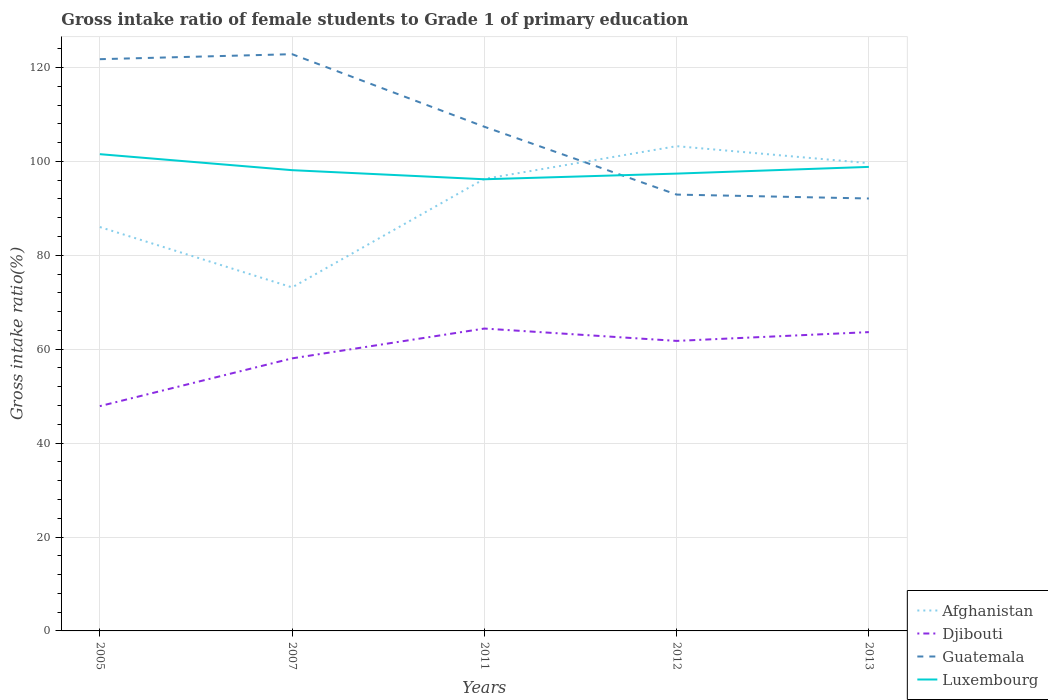Is the number of lines equal to the number of legend labels?
Keep it short and to the point. Yes. Across all years, what is the maximum gross intake ratio in Afghanistan?
Give a very brief answer. 73.16. In which year was the gross intake ratio in Luxembourg maximum?
Your answer should be compact. 2011. What is the total gross intake ratio in Guatemala in the graph?
Your response must be concise. 14.45. What is the difference between the highest and the second highest gross intake ratio in Djibouti?
Offer a very short reply. 16.52. What is the difference between the highest and the lowest gross intake ratio in Luxembourg?
Give a very brief answer. 2. How many lines are there?
Your answer should be compact. 4. What is the difference between two consecutive major ticks on the Y-axis?
Offer a very short reply. 20. Are the values on the major ticks of Y-axis written in scientific E-notation?
Keep it short and to the point. No. Does the graph contain any zero values?
Provide a short and direct response. No. Where does the legend appear in the graph?
Keep it short and to the point. Bottom right. How many legend labels are there?
Your answer should be compact. 4. How are the legend labels stacked?
Provide a short and direct response. Vertical. What is the title of the graph?
Keep it short and to the point. Gross intake ratio of female students to Grade 1 of primary education. Does "Sudan" appear as one of the legend labels in the graph?
Give a very brief answer. No. What is the label or title of the Y-axis?
Your answer should be compact. Gross intake ratio(%). What is the Gross intake ratio(%) of Afghanistan in 2005?
Provide a short and direct response. 86.01. What is the Gross intake ratio(%) in Djibouti in 2005?
Ensure brevity in your answer.  47.87. What is the Gross intake ratio(%) of Guatemala in 2005?
Keep it short and to the point. 121.76. What is the Gross intake ratio(%) in Luxembourg in 2005?
Your answer should be very brief. 101.53. What is the Gross intake ratio(%) of Afghanistan in 2007?
Provide a short and direct response. 73.16. What is the Gross intake ratio(%) of Djibouti in 2007?
Make the answer very short. 58.04. What is the Gross intake ratio(%) of Guatemala in 2007?
Ensure brevity in your answer.  122.83. What is the Gross intake ratio(%) of Luxembourg in 2007?
Offer a terse response. 98.12. What is the Gross intake ratio(%) of Afghanistan in 2011?
Provide a short and direct response. 96.27. What is the Gross intake ratio(%) of Djibouti in 2011?
Ensure brevity in your answer.  64.39. What is the Gross intake ratio(%) in Guatemala in 2011?
Ensure brevity in your answer.  107.37. What is the Gross intake ratio(%) in Luxembourg in 2011?
Give a very brief answer. 96.19. What is the Gross intake ratio(%) of Afghanistan in 2012?
Offer a terse response. 103.24. What is the Gross intake ratio(%) of Djibouti in 2012?
Keep it short and to the point. 61.76. What is the Gross intake ratio(%) in Guatemala in 2012?
Provide a short and direct response. 92.92. What is the Gross intake ratio(%) of Luxembourg in 2012?
Make the answer very short. 97.39. What is the Gross intake ratio(%) in Afghanistan in 2013?
Provide a succinct answer. 99.62. What is the Gross intake ratio(%) of Djibouti in 2013?
Offer a very short reply. 63.64. What is the Gross intake ratio(%) in Guatemala in 2013?
Your answer should be very brief. 92.09. What is the Gross intake ratio(%) of Luxembourg in 2013?
Keep it short and to the point. 98.82. Across all years, what is the maximum Gross intake ratio(%) in Afghanistan?
Provide a succinct answer. 103.24. Across all years, what is the maximum Gross intake ratio(%) in Djibouti?
Offer a terse response. 64.39. Across all years, what is the maximum Gross intake ratio(%) in Guatemala?
Keep it short and to the point. 122.83. Across all years, what is the maximum Gross intake ratio(%) in Luxembourg?
Keep it short and to the point. 101.53. Across all years, what is the minimum Gross intake ratio(%) of Afghanistan?
Keep it short and to the point. 73.16. Across all years, what is the minimum Gross intake ratio(%) of Djibouti?
Your response must be concise. 47.87. Across all years, what is the minimum Gross intake ratio(%) of Guatemala?
Provide a short and direct response. 92.09. Across all years, what is the minimum Gross intake ratio(%) in Luxembourg?
Your answer should be very brief. 96.19. What is the total Gross intake ratio(%) in Afghanistan in the graph?
Ensure brevity in your answer.  458.29. What is the total Gross intake ratio(%) in Djibouti in the graph?
Your answer should be very brief. 295.71. What is the total Gross intake ratio(%) of Guatemala in the graph?
Ensure brevity in your answer.  536.97. What is the total Gross intake ratio(%) in Luxembourg in the graph?
Make the answer very short. 492.05. What is the difference between the Gross intake ratio(%) of Afghanistan in 2005 and that in 2007?
Your response must be concise. 12.85. What is the difference between the Gross intake ratio(%) of Djibouti in 2005 and that in 2007?
Your answer should be very brief. -10.17. What is the difference between the Gross intake ratio(%) of Guatemala in 2005 and that in 2007?
Offer a very short reply. -1.07. What is the difference between the Gross intake ratio(%) of Luxembourg in 2005 and that in 2007?
Keep it short and to the point. 3.41. What is the difference between the Gross intake ratio(%) of Afghanistan in 2005 and that in 2011?
Your answer should be compact. -10.25. What is the difference between the Gross intake ratio(%) of Djibouti in 2005 and that in 2011?
Your answer should be compact. -16.52. What is the difference between the Gross intake ratio(%) of Guatemala in 2005 and that in 2011?
Provide a short and direct response. 14.39. What is the difference between the Gross intake ratio(%) of Luxembourg in 2005 and that in 2011?
Your response must be concise. 5.34. What is the difference between the Gross intake ratio(%) in Afghanistan in 2005 and that in 2012?
Offer a very short reply. -17.22. What is the difference between the Gross intake ratio(%) in Djibouti in 2005 and that in 2012?
Ensure brevity in your answer.  -13.89. What is the difference between the Gross intake ratio(%) of Guatemala in 2005 and that in 2012?
Provide a succinct answer. 28.83. What is the difference between the Gross intake ratio(%) of Luxembourg in 2005 and that in 2012?
Your answer should be compact. 4.14. What is the difference between the Gross intake ratio(%) in Afghanistan in 2005 and that in 2013?
Provide a short and direct response. -13.61. What is the difference between the Gross intake ratio(%) in Djibouti in 2005 and that in 2013?
Your response must be concise. -15.76. What is the difference between the Gross intake ratio(%) of Guatemala in 2005 and that in 2013?
Offer a terse response. 29.67. What is the difference between the Gross intake ratio(%) in Luxembourg in 2005 and that in 2013?
Make the answer very short. 2.71. What is the difference between the Gross intake ratio(%) in Afghanistan in 2007 and that in 2011?
Your answer should be very brief. -23.1. What is the difference between the Gross intake ratio(%) in Djibouti in 2007 and that in 2011?
Keep it short and to the point. -6.35. What is the difference between the Gross intake ratio(%) of Guatemala in 2007 and that in 2011?
Your answer should be very brief. 15.46. What is the difference between the Gross intake ratio(%) in Luxembourg in 2007 and that in 2011?
Keep it short and to the point. 1.94. What is the difference between the Gross intake ratio(%) in Afghanistan in 2007 and that in 2012?
Give a very brief answer. -30.07. What is the difference between the Gross intake ratio(%) in Djibouti in 2007 and that in 2012?
Your answer should be very brief. -3.72. What is the difference between the Gross intake ratio(%) of Guatemala in 2007 and that in 2012?
Provide a succinct answer. 29.9. What is the difference between the Gross intake ratio(%) of Luxembourg in 2007 and that in 2012?
Provide a succinct answer. 0.73. What is the difference between the Gross intake ratio(%) in Afghanistan in 2007 and that in 2013?
Your response must be concise. -26.46. What is the difference between the Gross intake ratio(%) in Djibouti in 2007 and that in 2013?
Your answer should be very brief. -5.59. What is the difference between the Gross intake ratio(%) of Guatemala in 2007 and that in 2013?
Provide a short and direct response. 30.73. What is the difference between the Gross intake ratio(%) of Luxembourg in 2007 and that in 2013?
Offer a terse response. -0.7. What is the difference between the Gross intake ratio(%) in Afghanistan in 2011 and that in 2012?
Keep it short and to the point. -6.97. What is the difference between the Gross intake ratio(%) in Djibouti in 2011 and that in 2012?
Offer a very short reply. 2.63. What is the difference between the Gross intake ratio(%) of Guatemala in 2011 and that in 2012?
Provide a succinct answer. 14.45. What is the difference between the Gross intake ratio(%) in Luxembourg in 2011 and that in 2012?
Your answer should be compact. -1.21. What is the difference between the Gross intake ratio(%) of Afghanistan in 2011 and that in 2013?
Your answer should be very brief. -3.35. What is the difference between the Gross intake ratio(%) of Djibouti in 2011 and that in 2013?
Offer a terse response. 0.76. What is the difference between the Gross intake ratio(%) of Guatemala in 2011 and that in 2013?
Ensure brevity in your answer.  15.28. What is the difference between the Gross intake ratio(%) of Luxembourg in 2011 and that in 2013?
Keep it short and to the point. -2.64. What is the difference between the Gross intake ratio(%) in Afghanistan in 2012 and that in 2013?
Keep it short and to the point. 3.62. What is the difference between the Gross intake ratio(%) of Djibouti in 2012 and that in 2013?
Your answer should be compact. -1.87. What is the difference between the Gross intake ratio(%) in Guatemala in 2012 and that in 2013?
Give a very brief answer. 0.83. What is the difference between the Gross intake ratio(%) in Luxembourg in 2012 and that in 2013?
Your answer should be compact. -1.43. What is the difference between the Gross intake ratio(%) of Afghanistan in 2005 and the Gross intake ratio(%) of Djibouti in 2007?
Your answer should be very brief. 27.97. What is the difference between the Gross intake ratio(%) of Afghanistan in 2005 and the Gross intake ratio(%) of Guatemala in 2007?
Your answer should be very brief. -36.81. What is the difference between the Gross intake ratio(%) of Afghanistan in 2005 and the Gross intake ratio(%) of Luxembourg in 2007?
Provide a succinct answer. -12.11. What is the difference between the Gross intake ratio(%) of Djibouti in 2005 and the Gross intake ratio(%) of Guatemala in 2007?
Your answer should be very brief. -74.95. What is the difference between the Gross intake ratio(%) in Djibouti in 2005 and the Gross intake ratio(%) in Luxembourg in 2007?
Your answer should be compact. -50.25. What is the difference between the Gross intake ratio(%) in Guatemala in 2005 and the Gross intake ratio(%) in Luxembourg in 2007?
Offer a very short reply. 23.64. What is the difference between the Gross intake ratio(%) in Afghanistan in 2005 and the Gross intake ratio(%) in Djibouti in 2011?
Offer a terse response. 21.62. What is the difference between the Gross intake ratio(%) of Afghanistan in 2005 and the Gross intake ratio(%) of Guatemala in 2011?
Ensure brevity in your answer.  -21.36. What is the difference between the Gross intake ratio(%) of Afghanistan in 2005 and the Gross intake ratio(%) of Luxembourg in 2011?
Ensure brevity in your answer.  -10.17. What is the difference between the Gross intake ratio(%) in Djibouti in 2005 and the Gross intake ratio(%) in Guatemala in 2011?
Offer a terse response. -59.5. What is the difference between the Gross intake ratio(%) of Djibouti in 2005 and the Gross intake ratio(%) of Luxembourg in 2011?
Give a very brief answer. -48.31. What is the difference between the Gross intake ratio(%) of Guatemala in 2005 and the Gross intake ratio(%) of Luxembourg in 2011?
Offer a terse response. 25.57. What is the difference between the Gross intake ratio(%) of Afghanistan in 2005 and the Gross intake ratio(%) of Djibouti in 2012?
Provide a succinct answer. 24.25. What is the difference between the Gross intake ratio(%) of Afghanistan in 2005 and the Gross intake ratio(%) of Guatemala in 2012?
Offer a very short reply. -6.91. What is the difference between the Gross intake ratio(%) of Afghanistan in 2005 and the Gross intake ratio(%) of Luxembourg in 2012?
Offer a terse response. -11.38. What is the difference between the Gross intake ratio(%) in Djibouti in 2005 and the Gross intake ratio(%) in Guatemala in 2012?
Your answer should be very brief. -45.05. What is the difference between the Gross intake ratio(%) in Djibouti in 2005 and the Gross intake ratio(%) in Luxembourg in 2012?
Provide a short and direct response. -49.52. What is the difference between the Gross intake ratio(%) of Guatemala in 2005 and the Gross intake ratio(%) of Luxembourg in 2012?
Ensure brevity in your answer.  24.37. What is the difference between the Gross intake ratio(%) of Afghanistan in 2005 and the Gross intake ratio(%) of Djibouti in 2013?
Offer a terse response. 22.38. What is the difference between the Gross intake ratio(%) of Afghanistan in 2005 and the Gross intake ratio(%) of Guatemala in 2013?
Offer a terse response. -6.08. What is the difference between the Gross intake ratio(%) of Afghanistan in 2005 and the Gross intake ratio(%) of Luxembourg in 2013?
Make the answer very short. -12.81. What is the difference between the Gross intake ratio(%) in Djibouti in 2005 and the Gross intake ratio(%) in Guatemala in 2013?
Provide a short and direct response. -44.22. What is the difference between the Gross intake ratio(%) in Djibouti in 2005 and the Gross intake ratio(%) in Luxembourg in 2013?
Your response must be concise. -50.95. What is the difference between the Gross intake ratio(%) in Guatemala in 2005 and the Gross intake ratio(%) in Luxembourg in 2013?
Make the answer very short. 22.93. What is the difference between the Gross intake ratio(%) in Afghanistan in 2007 and the Gross intake ratio(%) in Djibouti in 2011?
Keep it short and to the point. 8.77. What is the difference between the Gross intake ratio(%) of Afghanistan in 2007 and the Gross intake ratio(%) of Guatemala in 2011?
Your answer should be very brief. -34.21. What is the difference between the Gross intake ratio(%) of Afghanistan in 2007 and the Gross intake ratio(%) of Luxembourg in 2011?
Your answer should be compact. -23.02. What is the difference between the Gross intake ratio(%) of Djibouti in 2007 and the Gross intake ratio(%) of Guatemala in 2011?
Keep it short and to the point. -49.33. What is the difference between the Gross intake ratio(%) in Djibouti in 2007 and the Gross intake ratio(%) in Luxembourg in 2011?
Your answer should be very brief. -38.14. What is the difference between the Gross intake ratio(%) in Guatemala in 2007 and the Gross intake ratio(%) in Luxembourg in 2011?
Ensure brevity in your answer.  26.64. What is the difference between the Gross intake ratio(%) in Afghanistan in 2007 and the Gross intake ratio(%) in Djibouti in 2012?
Your response must be concise. 11.4. What is the difference between the Gross intake ratio(%) of Afghanistan in 2007 and the Gross intake ratio(%) of Guatemala in 2012?
Offer a terse response. -19.76. What is the difference between the Gross intake ratio(%) of Afghanistan in 2007 and the Gross intake ratio(%) of Luxembourg in 2012?
Provide a short and direct response. -24.23. What is the difference between the Gross intake ratio(%) in Djibouti in 2007 and the Gross intake ratio(%) in Guatemala in 2012?
Give a very brief answer. -34.88. What is the difference between the Gross intake ratio(%) in Djibouti in 2007 and the Gross intake ratio(%) in Luxembourg in 2012?
Provide a succinct answer. -39.35. What is the difference between the Gross intake ratio(%) in Guatemala in 2007 and the Gross intake ratio(%) in Luxembourg in 2012?
Your answer should be very brief. 25.43. What is the difference between the Gross intake ratio(%) in Afghanistan in 2007 and the Gross intake ratio(%) in Djibouti in 2013?
Keep it short and to the point. 9.53. What is the difference between the Gross intake ratio(%) of Afghanistan in 2007 and the Gross intake ratio(%) of Guatemala in 2013?
Make the answer very short. -18.93. What is the difference between the Gross intake ratio(%) in Afghanistan in 2007 and the Gross intake ratio(%) in Luxembourg in 2013?
Keep it short and to the point. -25.66. What is the difference between the Gross intake ratio(%) of Djibouti in 2007 and the Gross intake ratio(%) of Guatemala in 2013?
Make the answer very short. -34.05. What is the difference between the Gross intake ratio(%) of Djibouti in 2007 and the Gross intake ratio(%) of Luxembourg in 2013?
Your answer should be very brief. -40.78. What is the difference between the Gross intake ratio(%) of Guatemala in 2007 and the Gross intake ratio(%) of Luxembourg in 2013?
Ensure brevity in your answer.  24. What is the difference between the Gross intake ratio(%) in Afghanistan in 2011 and the Gross intake ratio(%) in Djibouti in 2012?
Ensure brevity in your answer.  34.5. What is the difference between the Gross intake ratio(%) in Afghanistan in 2011 and the Gross intake ratio(%) in Guatemala in 2012?
Provide a succinct answer. 3.34. What is the difference between the Gross intake ratio(%) in Afghanistan in 2011 and the Gross intake ratio(%) in Luxembourg in 2012?
Ensure brevity in your answer.  -1.13. What is the difference between the Gross intake ratio(%) in Djibouti in 2011 and the Gross intake ratio(%) in Guatemala in 2012?
Ensure brevity in your answer.  -28.53. What is the difference between the Gross intake ratio(%) in Djibouti in 2011 and the Gross intake ratio(%) in Luxembourg in 2012?
Make the answer very short. -33. What is the difference between the Gross intake ratio(%) in Guatemala in 2011 and the Gross intake ratio(%) in Luxembourg in 2012?
Ensure brevity in your answer.  9.98. What is the difference between the Gross intake ratio(%) of Afghanistan in 2011 and the Gross intake ratio(%) of Djibouti in 2013?
Keep it short and to the point. 32.63. What is the difference between the Gross intake ratio(%) in Afghanistan in 2011 and the Gross intake ratio(%) in Guatemala in 2013?
Your response must be concise. 4.17. What is the difference between the Gross intake ratio(%) in Afghanistan in 2011 and the Gross intake ratio(%) in Luxembourg in 2013?
Keep it short and to the point. -2.56. What is the difference between the Gross intake ratio(%) of Djibouti in 2011 and the Gross intake ratio(%) of Guatemala in 2013?
Offer a very short reply. -27.7. What is the difference between the Gross intake ratio(%) of Djibouti in 2011 and the Gross intake ratio(%) of Luxembourg in 2013?
Give a very brief answer. -34.43. What is the difference between the Gross intake ratio(%) of Guatemala in 2011 and the Gross intake ratio(%) of Luxembourg in 2013?
Your answer should be compact. 8.55. What is the difference between the Gross intake ratio(%) of Afghanistan in 2012 and the Gross intake ratio(%) of Djibouti in 2013?
Your answer should be very brief. 39.6. What is the difference between the Gross intake ratio(%) of Afghanistan in 2012 and the Gross intake ratio(%) of Guatemala in 2013?
Ensure brevity in your answer.  11.14. What is the difference between the Gross intake ratio(%) of Afghanistan in 2012 and the Gross intake ratio(%) of Luxembourg in 2013?
Make the answer very short. 4.41. What is the difference between the Gross intake ratio(%) of Djibouti in 2012 and the Gross intake ratio(%) of Guatemala in 2013?
Ensure brevity in your answer.  -30.33. What is the difference between the Gross intake ratio(%) in Djibouti in 2012 and the Gross intake ratio(%) in Luxembourg in 2013?
Provide a short and direct response. -37.06. What is the difference between the Gross intake ratio(%) in Guatemala in 2012 and the Gross intake ratio(%) in Luxembourg in 2013?
Your answer should be very brief. -5.9. What is the average Gross intake ratio(%) of Afghanistan per year?
Your answer should be very brief. 91.66. What is the average Gross intake ratio(%) in Djibouti per year?
Offer a terse response. 59.14. What is the average Gross intake ratio(%) in Guatemala per year?
Give a very brief answer. 107.39. What is the average Gross intake ratio(%) of Luxembourg per year?
Give a very brief answer. 98.41. In the year 2005, what is the difference between the Gross intake ratio(%) of Afghanistan and Gross intake ratio(%) of Djibouti?
Make the answer very short. 38.14. In the year 2005, what is the difference between the Gross intake ratio(%) in Afghanistan and Gross intake ratio(%) in Guatemala?
Your answer should be compact. -35.74. In the year 2005, what is the difference between the Gross intake ratio(%) of Afghanistan and Gross intake ratio(%) of Luxembourg?
Offer a terse response. -15.52. In the year 2005, what is the difference between the Gross intake ratio(%) of Djibouti and Gross intake ratio(%) of Guatemala?
Provide a succinct answer. -73.88. In the year 2005, what is the difference between the Gross intake ratio(%) of Djibouti and Gross intake ratio(%) of Luxembourg?
Give a very brief answer. -53.66. In the year 2005, what is the difference between the Gross intake ratio(%) of Guatemala and Gross intake ratio(%) of Luxembourg?
Make the answer very short. 20.23. In the year 2007, what is the difference between the Gross intake ratio(%) of Afghanistan and Gross intake ratio(%) of Djibouti?
Your answer should be very brief. 15.12. In the year 2007, what is the difference between the Gross intake ratio(%) in Afghanistan and Gross intake ratio(%) in Guatemala?
Your answer should be compact. -49.66. In the year 2007, what is the difference between the Gross intake ratio(%) of Afghanistan and Gross intake ratio(%) of Luxembourg?
Your answer should be compact. -24.96. In the year 2007, what is the difference between the Gross intake ratio(%) of Djibouti and Gross intake ratio(%) of Guatemala?
Ensure brevity in your answer.  -64.78. In the year 2007, what is the difference between the Gross intake ratio(%) in Djibouti and Gross intake ratio(%) in Luxembourg?
Make the answer very short. -40.08. In the year 2007, what is the difference between the Gross intake ratio(%) in Guatemala and Gross intake ratio(%) in Luxembourg?
Provide a short and direct response. 24.7. In the year 2011, what is the difference between the Gross intake ratio(%) in Afghanistan and Gross intake ratio(%) in Djibouti?
Offer a very short reply. 31.87. In the year 2011, what is the difference between the Gross intake ratio(%) of Afghanistan and Gross intake ratio(%) of Guatemala?
Provide a short and direct response. -11.11. In the year 2011, what is the difference between the Gross intake ratio(%) in Afghanistan and Gross intake ratio(%) in Luxembourg?
Your answer should be very brief. 0.08. In the year 2011, what is the difference between the Gross intake ratio(%) of Djibouti and Gross intake ratio(%) of Guatemala?
Provide a succinct answer. -42.98. In the year 2011, what is the difference between the Gross intake ratio(%) in Djibouti and Gross intake ratio(%) in Luxembourg?
Give a very brief answer. -31.79. In the year 2011, what is the difference between the Gross intake ratio(%) of Guatemala and Gross intake ratio(%) of Luxembourg?
Make the answer very short. 11.18. In the year 2012, what is the difference between the Gross intake ratio(%) in Afghanistan and Gross intake ratio(%) in Djibouti?
Provide a short and direct response. 41.47. In the year 2012, what is the difference between the Gross intake ratio(%) of Afghanistan and Gross intake ratio(%) of Guatemala?
Offer a terse response. 10.31. In the year 2012, what is the difference between the Gross intake ratio(%) of Afghanistan and Gross intake ratio(%) of Luxembourg?
Offer a very short reply. 5.84. In the year 2012, what is the difference between the Gross intake ratio(%) in Djibouti and Gross intake ratio(%) in Guatemala?
Offer a very short reply. -31.16. In the year 2012, what is the difference between the Gross intake ratio(%) of Djibouti and Gross intake ratio(%) of Luxembourg?
Ensure brevity in your answer.  -35.63. In the year 2012, what is the difference between the Gross intake ratio(%) in Guatemala and Gross intake ratio(%) in Luxembourg?
Provide a succinct answer. -4.47. In the year 2013, what is the difference between the Gross intake ratio(%) of Afghanistan and Gross intake ratio(%) of Djibouti?
Provide a succinct answer. 35.98. In the year 2013, what is the difference between the Gross intake ratio(%) of Afghanistan and Gross intake ratio(%) of Guatemala?
Your answer should be very brief. 7.53. In the year 2013, what is the difference between the Gross intake ratio(%) of Afghanistan and Gross intake ratio(%) of Luxembourg?
Your answer should be very brief. 0.8. In the year 2013, what is the difference between the Gross intake ratio(%) in Djibouti and Gross intake ratio(%) in Guatemala?
Provide a succinct answer. -28.46. In the year 2013, what is the difference between the Gross intake ratio(%) in Djibouti and Gross intake ratio(%) in Luxembourg?
Ensure brevity in your answer.  -35.19. In the year 2013, what is the difference between the Gross intake ratio(%) in Guatemala and Gross intake ratio(%) in Luxembourg?
Offer a terse response. -6.73. What is the ratio of the Gross intake ratio(%) in Afghanistan in 2005 to that in 2007?
Make the answer very short. 1.18. What is the ratio of the Gross intake ratio(%) of Djibouti in 2005 to that in 2007?
Offer a very short reply. 0.82. What is the ratio of the Gross intake ratio(%) of Luxembourg in 2005 to that in 2007?
Give a very brief answer. 1.03. What is the ratio of the Gross intake ratio(%) in Afghanistan in 2005 to that in 2011?
Keep it short and to the point. 0.89. What is the ratio of the Gross intake ratio(%) of Djibouti in 2005 to that in 2011?
Make the answer very short. 0.74. What is the ratio of the Gross intake ratio(%) of Guatemala in 2005 to that in 2011?
Keep it short and to the point. 1.13. What is the ratio of the Gross intake ratio(%) of Luxembourg in 2005 to that in 2011?
Make the answer very short. 1.06. What is the ratio of the Gross intake ratio(%) of Afghanistan in 2005 to that in 2012?
Offer a terse response. 0.83. What is the ratio of the Gross intake ratio(%) in Djibouti in 2005 to that in 2012?
Offer a terse response. 0.78. What is the ratio of the Gross intake ratio(%) of Guatemala in 2005 to that in 2012?
Keep it short and to the point. 1.31. What is the ratio of the Gross intake ratio(%) in Luxembourg in 2005 to that in 2012?
Ensure brevity in your answer.  1.04. What is the ratio of the Gross intake ratio(%) in Afghanistan in 2005 to that in 2013?
Offer a terse response. 0.86. What is the ratio of the Gross intake ratio(%) of Djibouti in 2005 to that in 2013?
Keep it short and to the point. 0.75. What is the ratio of the Gross intake ratio(%) of Guatemala in 2005 to that in 2013?
Offer a terse response. 1.32. What is the ratio of the Gross intake ratio(%) of Luxembourg in 2005 to that in 2013?
Provide a succinct answer. 1.03. What is the ratio of the Gross intake ratio(%) of Afghanistan in 2007 to that in 2011?
Provide a succinct answer. 0.76. What is the ratio of the Gross intake ratio(%) in Djibouti in 2007 to that in 2011?
Keep it short and to the point. 0.9. What is the ratio of the Gross intake ratio(%) of Guatemala in 2007 to that in 2011?
Your answer should be very brief. 1.14. What is the ratio of the Gross intake ratio(%) in Luxembourg in 2007 to that in 2011?
Give a very brief answer. 1.02. What is the ratio of the Gross intake ratio(%) in Afghanistan in 2007 to that in 2012?
Make the answer very short. 0.71. What is the ratio of the Gross intake ratio(%) in Djibouti in 2007 to that in 2012?
Your answer should be very brief. 0.94. What is the ratio of the Gross intake ratio(%) in Guatemala in 2007 to that in 2012?
Provide a succinct answer. 1.32. What is the ratio of the Gross intake ratio(%) in Luxembourg in 2007 to that in 2012?
Offer a very short reply. 1.01. What is the ratio of the Gross intake ratio(%) of Afghanistan in 2007 to that in 2013?
Your answer should be compact. 0.73. What is the ratio of the Gross intake ratio(%) of Djibouti in 2007 to that in 2013?
Give a very brief answer. 0.91. What is the ratio of the Gross intake ratio(%) in Guatemala in 2007 to that in 2013?
Provide a succinct answer. 1.33. What is the ratio of the Gross intake ratio(%) of Afghanistan in 2011 to that in 2012?
Offer a very short reply. 0.93. What is the ratio of the Gross intake ratio(%) of Djibouti in 2011 to that in 2012?
Offer a very short reply. 1.04. What is the ratio of the Gross intake ratio(%) in Guatemala in 2011 to that in 2012?
Ensure brevity in your answer.  1.16. What is the ratio of the Gross intake ratio(%) of Luxembourg in 2011 to that in 2012?
Your answer should be very brief. 0.99. What is the ratio of the Gross intake ratio(%) in Afghanistan in 2011 to that in 2013?
Make the answer very short. 0.97. What is the ratio of the Gross intake ratio(%) of Djibouti in 2011 to that in 2013?
Your answer should be compact. 1.01. What is the ratio of the Gross intake ratio(%) in Guatemala in 2011 to that in 2013?
Offer a very short reply. 1.17. What is the ratio of the Gross intake ratio(%) in Luxembourg in 2011 to that in 2013?
Provide a succinct answer. 0.97. What is the ratio of the Gross intake ratio(%) of Afghanistan in 2012 to that in 2013?
Give a very brief answer. 1.04. What is the ratio of the Gross intake ratio(%) of Djibouti in 2012 to that in 2013?
Your response must be concise. 0.97. What is the ratio of the Gross intake ratio(%) in Guatemala in 2012 to that in 2013?
Offer a terse response. 1.01. What is the ratio of the Gross intake ratio(%) in Luxembourg in 2012 to that in 2013?
Ensure brevity in your answer.  0.99. What is the difference between the highest and the second highest Gross intake ratio(%) of Afghanistan?
Offer a very short reply. 3.62. What is the difference between the highest and the second highest Gross intake ratio(%) in Djibouti?
Ensure brevity in your answer.  0.76. What is the difference between the highest and the second highest Gross intake ratio(%) in Guatemala?
Ensure brevity in your answer.  1.07. What is the difference between the highest and the second highest Gross intake ratio(%) in Luxembourg?
Offer a terse response. 2.71. What is the difference between the highest and the lowest Gross intake ratio(%) of Afghanistan?
Make the answer very short. 30.07. What is the difference between the highest and the lowest Gross intake ratio(%) of Djibouti?
Give a very brief answer. 16.52. What is the difference between the highest and the lowest Gross intake ratio(%) of Guatemala?
Offer a very short reply. 30.73. What is the difference between the highest and the lowest Gross intake ratio(%) of Luxembourg?
Your answer should be compact. 5.34. 